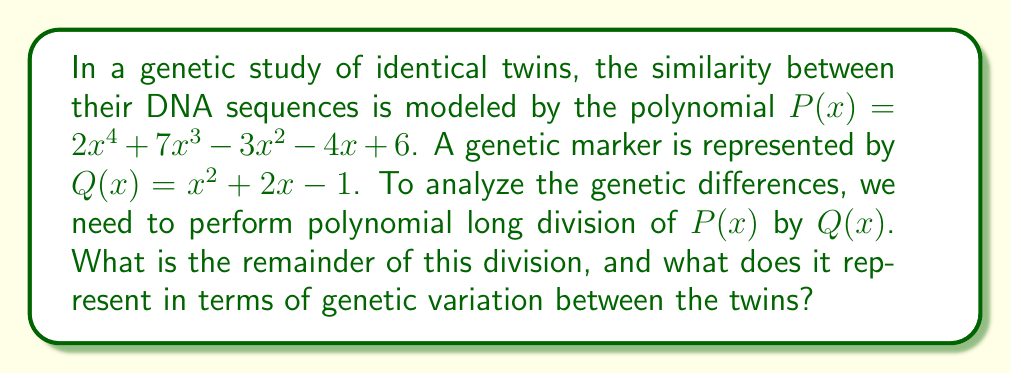Solve this math problem. Let's perform polynomial long division of $P(x)$ by $Q(x)$:

$$\begin{array}{r}
2x^2 + 3x - 1 \\
x^2 + 2x - 1 \enclose{longdiv}{2x^4 + 7x^3 - 3x^2 - 4x + 6} \\
\underline{2x^4 + 4x^3 - 2x^2} \\
3x^3 - x^2 - 4x + 6 \\
\underline{3x^3 + 6x^2 - 3x} \\
-7x^2 - x + 6 \\
\underline{-7x^2 - 14x + 7} \\
13x - 1
\end{array}$$

Step 1: Divide $2x^4$ by $x^2$ to get $2x^2$ as the first term of the quotient.
Step 2: Multiply $(2x^2)(x^2 + 2x - 1) = 2x^4 + 4x^3 - 2x^2$ and subtract from $P(x)$.
Step 3: Bring down the remaining terms.
Step 4: Repeat the process with $3x^3$ divided by $x^2$ to get $3x$ as the next term of the quotient.
Step 5: Continue until the degree of the remainder is less than the degree of $Q(x)$.

The final result is:
$P(x) = (2x^2 + 3x - 1)Q(x) + (13x - 1)$

The remainder is $13x - 1$, which represents the genetic variation between the twins that cannot be explained by the genetic marker $Q(x)$. The coefficient 13 might indicate the number of genetic differences, while the constant term -1 could represent a baseline similarity.
Answer: $13x - 1$ 